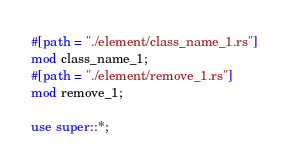Convert code to text. <code><loc_0><loc_0><loc_500><loc_500><_Rust_>#[path = "./element/class_name_1.rs"]
mod class_name_1;
#[path = "./element/remove_1.rs"]
mod remove_1;

use super::*;
</code> 